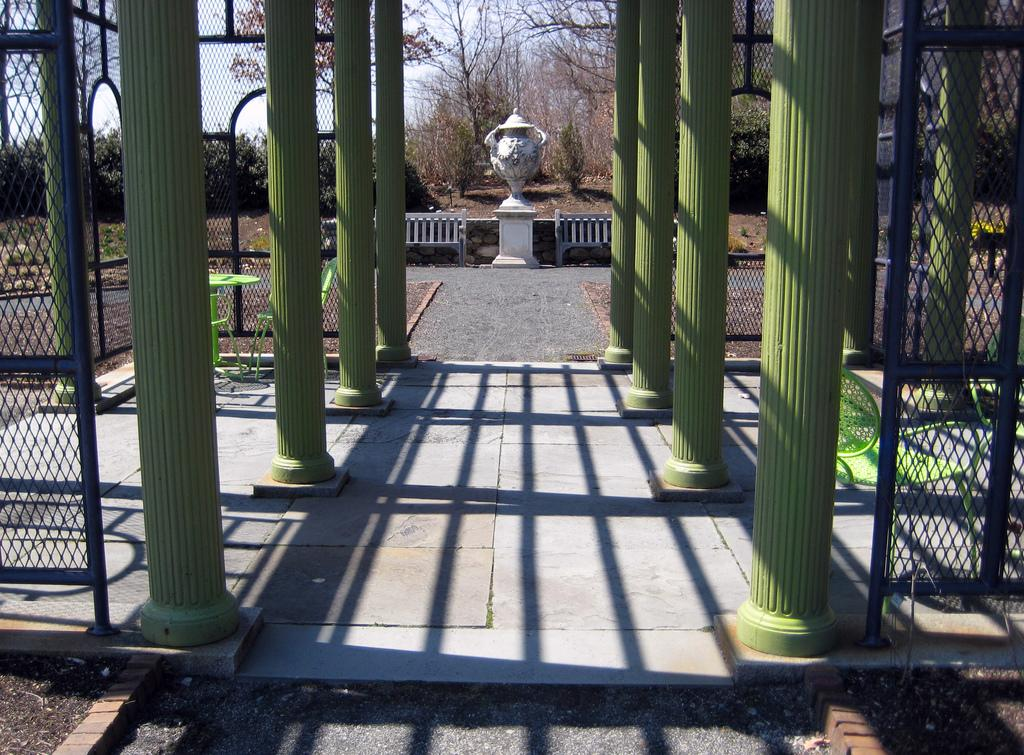What type of structure can be seen in the image? There is a fence and pillars in the image, which suggests a structure of some kind. What is the purpose of the structure in the image? There is a memorial in the image, indicating that the structure is likely a memorial site. What type of vegetation is present in the image? There are trees in the image. What is visible in the background of the image? The sky is visible in the image. Can you determine the time of day the image was taken? The image was likely taken during the day, as the sky is visible and not dark. Where is the cheese located in the image? There is no cheese present in the image. What type of toad can be seen sitting on the memorial in the image? There is no toad present in the image; it is a memorial site and not a habitat for toads. 